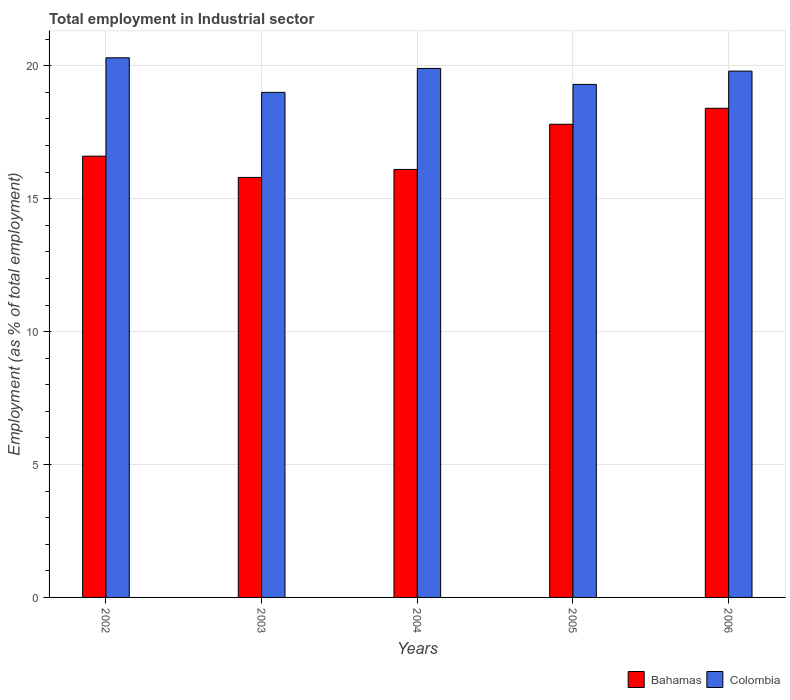How many groups of bars are there?
Your answer should be very brief. 5. Are the number of bars per tick equal to the number of legend labels?
Offer a terse response. Yes. Are the number of bars on each tick of the X-axis equal?
Ensure brevity in your answer.  Yes. How many bars are there on the 5th tick from the left?
Provide a succinct answer. 2. How many bars are there on the 1st tick from the right?
Provide a short and direct response. 2. What is the label of the 2nd group of bars from the left?
Offer a terse response. 2003. What is the employment in industrial sector in Colombia in 2004?
Offer a very short reply. 19.9. Across all years, what is the maximum employment in industrial sector in Bahamas?
Provide a short and direct response. 18.4. What is the total employment in industrial sector in Bahamas in the graph?
Make the answer very short. 84.7. What is the difference between the employment in industrial sector in Bahamas in 2003 and that in 2004?
Provide a succinct answer. -0.3. What is the difference between the employment in industrial sector in Bahamas in 2003 and the employment in industrial sector in Colombia in 2005?
Offer a very short reply. -3.5. What is the average employment in industrial sector in Bahamas per year?
Make the answer very short. 16.94. In the year 2006, what is the difference between the employment in industrial sector in Colombia and employment in industrial sector in Bahamas?
Your response must be concise. 1.4. What is the ratio of the employment in industrial sector in Bahamas in 2003 to that in 2004?
Keep it short and to the point. 0.98. What is the difference between the highest and the second highest employment in industrial sector in Bahamas?
Your answer should be compact. 0.6. What is the difference between the highest and the lowest employment in industrial sector in Colombia?
Provide a short and direct response. 1.3. Is the sum of the employment in industrial sector in Bahamas in 2004 and 2006 greater than the maximum employment in industrial sector in Colombia across all years?
Make the answer very short. Yes. What does the 2nd bar from the left in 2002 represents?
Your answer should be very brief. Colombia. What does the 2nd bar from the right in 2006 represents?
Keep it short and to the point. Bahamas. How many bars are there?
Ensure brevity in your answer.  10. Are all the bars in the graph horizontal?
Provide a short and direct response. No. How many years are there in the graph?
Your response must be concise. 5. What is the difference between two consecutive major ticks on the Y-axis?
Ensure brevity in your answer.  5. Does the graph contain any zero values?
Give a very brief answer. No. How many legend labels are there?
Ensure brevity in your answer.  2. How are the legend labels stacked?
Your response must be concise. Horizontal. What is the title of the graph?
Keep it short and to the point. Total employment in Industrial sector. What is the label or title of the Y-axis?
Give a very brief answer. Employment (as % of total employment). What is the Employment (as % of total employment) of Bahamas in 2002?
Make the answer very short. 16.6. What is the Employment (as % of total employment) of Colombia in 2002?
Your response must be concise. 20.3. What is the Employment (as % of total employment) in Bahamas in 2003?
Keep it short and to the point. 15.8. What is the Employment (as % of total employment) in Bahamas in 2004?
Your answer should be very brief. 16.1. What is the Employment (as % of total employment) in Colombia in 2004?
Your answer should be very brief. 19.9. What is the Employment (as % of total employment) of Bahamas in 2005?
Your answer should be very brief. 17.8. What is the Employment (as % of total employment) in Colombia in 2005?
Your response must be concise. 19.3. What is the Employment (as % of total employment) of Bahamas in 2006?
Offer a very short reply. 18.4. What is the Employment (as % of total employment) of Colombia in 2006?
Offer a very short reply. 19.8. Across all years, what is the maximum Employment (as % of total employment) in Bahamas?
Provide a short and direct response. 18.4. Across all years, what is the maximum Employment (as % of total employment) in Colombia?
Ensure brevity in your answer.  20.3. Across all years, what is the minimum Employment (as % of total employment) of Bahamas?
Give a very brief answer. 15.8. What is the total Employment (as % of total employment) of Bahamas in the graph?
Your answer should be very brief. 84.7. What is the total Employment (as % of total employment) in Colombia in the graph?
Your response must be concise. 98.3. What is the difference between the Employment (as % of total employment) in Bahamas in 2002 and that in 2003?
Your answer should be compact. 0.8. What is the difference between the Employment (as % of total employment) of Colombia in 2002 and that in 2003?
Offer a very short reply. 1.3. What is the difference between the Employment (as % of total employment) of Colombia in 2002 and that in 2006?
Offer a terse response. 0.5. What is the difference between the Employment (as % of total employment) of Bahamas in 2003 and that in 2005?
Offer a very short reply. -2. What is the difference between the Employment (as % of total employment) in Colombia in 2003 and that in 2005?
Your answer should be compact. -0.3. What is the difference between the Employment (as % of total employment) of Bahamas in 2003 and that in 2006?
Ensure brevity in your answer.  -2.6. What is the difference between the Employment (as % of total employment) of Colombia in 2003 and that in 2006?
Make the answer very short. -0.8. What is the difference between the Employment (as % of total employment) of Bahamas in 2004 and that in 2005?
Your response must be concise. -1.7. What is the difference between the Employment (as % of total employment) in Colombia in 2004 and that in 2005?
Provide a succinct answer. 0.6. What is the difference between the Employment (as % of total employment) in Colombia in 2004 and that in 2006?
Your response must be concise. 0.1. What is the difference between the Employment (as % of total employment) of Bahamas in 2005 and that in 2006?
Offer a very short reply. -0.6. What is the difference between the Employment (as % of total employment) in Colombia in 2005 and that in 2006?
Make the answer very short. -0.5. What is the difference between the Employment (as % of total employment) of Bahamas in 2002 and the Employment (as % of total employment) of Colombia in 2003?
Your response must be concise. -2.4. What is the difference between the Employment (as % of total employment) in Bahamas in 2003 and the Employment (as % of total employment) in Colombia in 2005?
Provide a short and direct response. -3.5. What is the difference between the Employment (as % of total employment) in Bahamas in 2003 and the Employment (as % of total employment) in Colombia in 2006?
Offer a terse response. -4. What is the difference between the Employment (as % of total employment) in Bahamas in 2004 and the Employment (as % of total employment) in Colombia in 2006?
Offer a terse response. -3.7. What is the average Employment (as % of total employment) in Bahamas per year?
Offer a very short reply. 16.94. What is the average Employment (as % of total employment) in Colombia per year?
Provide a succinct answer. 19.66. In the year 2002, what is the difference between the Employment (as % of total employment) of Bahamas and Employment (as % of total employment) of Colombia?
Your answer should be compact. -3.7. In the year 2006, what is the difference between the Employment (as % of total employment) in Bahamas and Employment (as % of total employment) in Colombia?
Offer a terse response. -1.4. What is the ratio of the Employment (as % of total employment) in Bahamas in 2002 to that in 2003?
Offer a very short reply. 1.05. What is the ratio of the Employment (as % of total employment) of Colombia in 2002 to that in 2003?
Offer a terse response. 1.07. What is the ratio of the Employment (as % of total employment) of Bahamas in 2002 to that in 2004?
Give a very brief answer. 1.03. What is the ratio of the Employment (as % of total employment) of Colombia in 2002 to that in 2004?
Your response must be concise. 1.02. What is the ratio of the Employment (as % of total employment) of Bahamas in 2002 to that in 2005?
Provide a short and direct response. 0.93. What is the ratio of the Employment (as % of total employment) in Colombia in 2002 to that in 2005?
Offer a terse response. 1.05. What is the ratio of the Employment (as % of total employment) of Bahamas in 2002 to that in 2006?
Ensure brevity in your answer.  0.9. What is the ratio of the Employment (as % of total employment) of Colombia in 2002 to that in 2006?
Your answer should be compact. 1.03. What is the ratio of the Employment (as % of total employment) of Bahamas in 2003 to that in 2004?
Offer a very short reply. 0.98. What is the ratio of the Employment (as % of total employment) in Colombia in 2003 to that in 2004?
Keep it short and to the point. 0.95. What is the ratio of the Employment (as % of total employment) of Bahamas in 2003 to that in 2005?
Your answer should be very brief. 0.89. What is the ratio of the Employment (as % of total employment) in Colombia in 2003 to that in 2005?
Give a very brief answer. 0.98. What is the ratio of the Employment (as % of total employment) of Bahamas in 2003 to that in 2006?
Offer a very short reply. 0.86. What is the ratio of the Employment (as % of total employment) in Colombia in 2003 to that in 2006?
Give a very brief answer. 0.96. What is the ratio of the Employment (as % of total employment) of Bahamas in 2004 to that in 2005?
Provide a succinct answer. 0.9. What is the ratio of the Employment (as % of total employment) of Colombia in 2004 to that in 2005?
Provide a succinct answer. 1.03. What is the ratio of the Employment (as % of total employment) of Bahamas in 2004 to that in 2006?
Offer a very short reply. 0.88. What is the ratio of the Employment (as % of total employment) in Colombia in 2004 to that in 2006?
Offer a very short reply. 1.01. What is the ratio of the Employment (as % of total employment) in Bahamas in 2005 to that in 2006?
Ensure brevity in your answer.  0.97. What is the ratio of the Employment (as % of total employment) in Colombia in 2005 to that in 2006?
Provide a short and direct response. 0.97. What is the difference between the highest and the second highest Employment (as % of total employment) in Bahamas?
Ensure brevity in your answer.  0.6. What is the difference between the highest and the lowest Employment (as % of total employment) in Bahamas?
Make the answer very short. 2.6. 